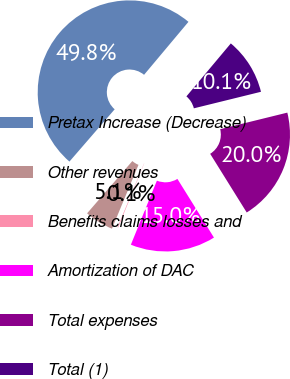<chart> <loc_0><loc_0><loc_500><loc_500><pie_chart><fcel>Pretax Increase (Decrease)<fcel>Other revenues<fcel>Benefits claims losses and<fcel>Amortization of DAC<fcel>Total expenses<fcel>Total (1)<nl><fcel>49.75%<fcel>5.09%<fcel>0.12%<fcel>15.01%<fcel>19.98%<fcel>10.05%<nl></chart> 